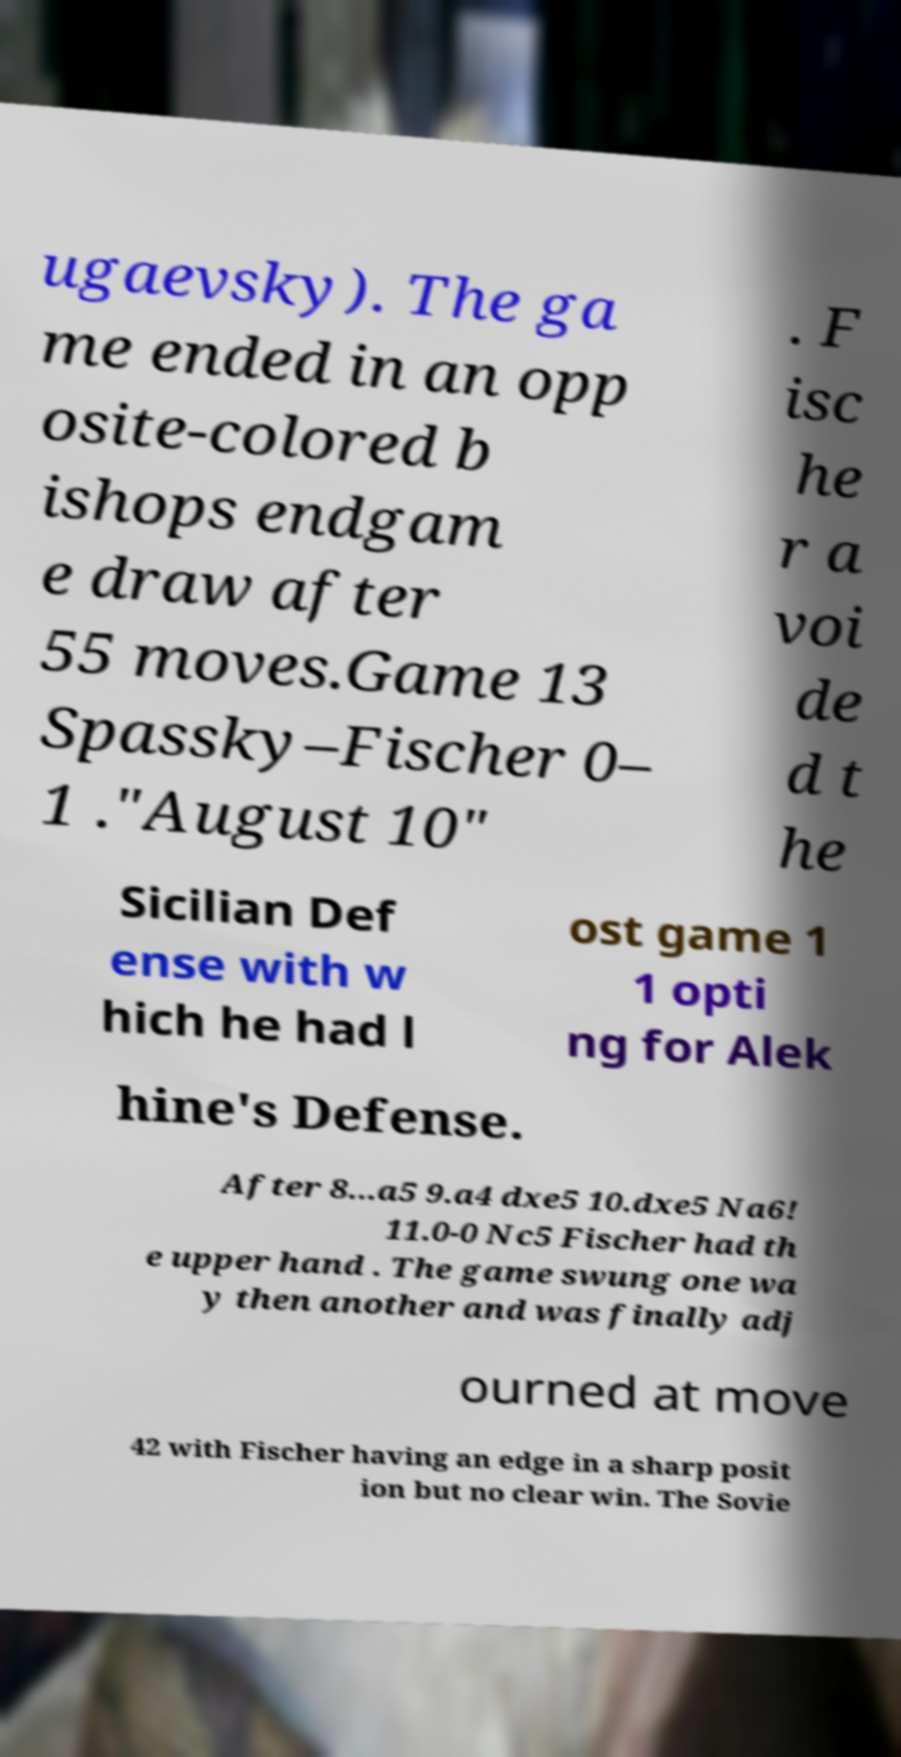What messages or text are displayed in this image? I need them in a readable, typed format. ugaevsky). The ga me ended in an opp osite-colored b ishops endgam e draw after 55 moves.Game 13 Spassky–Fischer 0– 1 ."August 10" . F isc he r a voi de d t he Sicilian Def ense with w hich he had l ost game 1 1 opti ng for Alek hine's Defense. After 8...a5 9.a4 dxe5 10.dxe5 Na6! 11.0-0 Nc5 Fischer had th e upper hand . The game swung one wa y then another and was finally adj ourned at move 42 with Fischer having an edge in a sharp posit ion but no clear win. The Sovie 